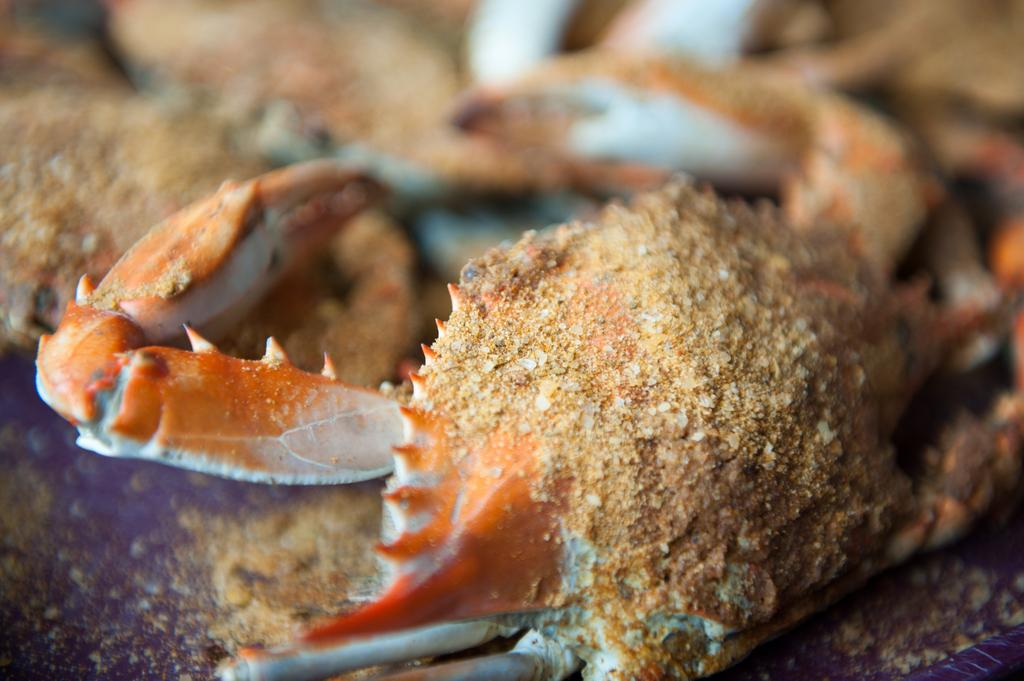What type of animal is in the image? There is a crab in the image. Where is the crab located? The crab is placed on a surface. What type of vein is visible in the image? There is no vein present in the image; it features a crab placed on a surface. 